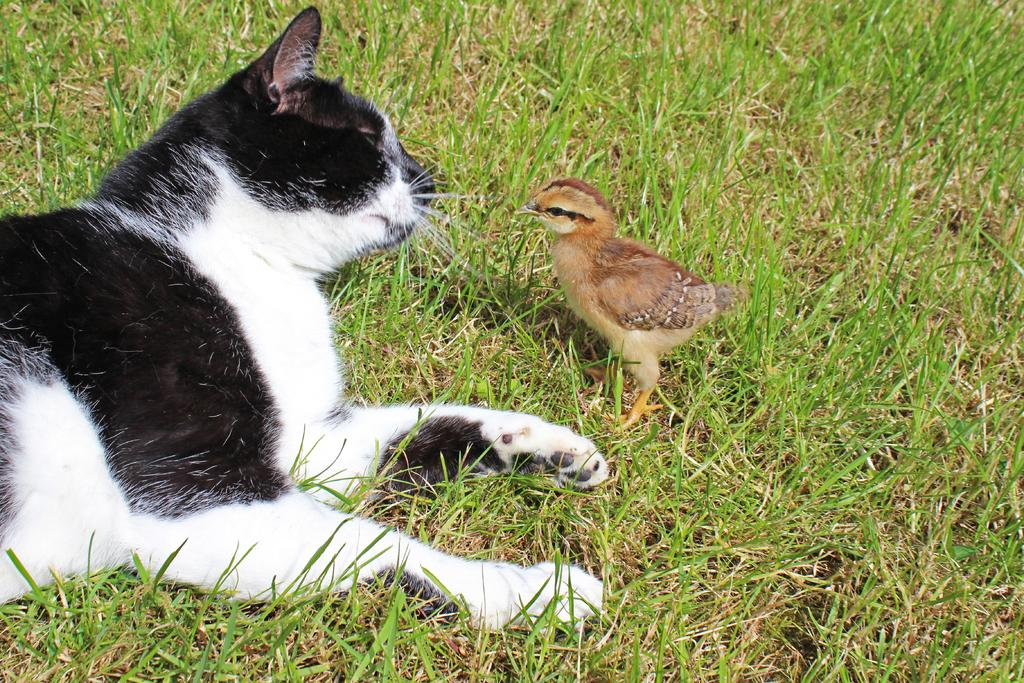What type of animal is in the image? There is a black and white cat in the image. What is the cat's interaction with another animal in the image? There is a bird looking at the cat in the image. Can you describe the position of the bird in the image? There is a bird standing on the ground in the image. What type of rice is being cooked in the image? There is no rice present in the image; it features a black and white cat and a bird. 